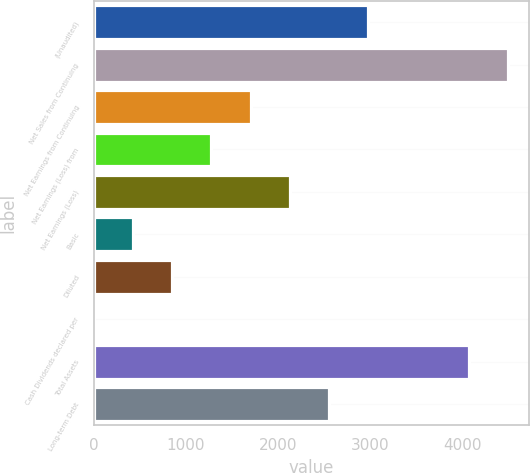<chart> <loc_0><loc_0><loc_500><loc_500><bar_chart><fcel>(Unaudited)<fcel>Net Sales from Continuing<fcel>Net Earnings from Continuing<fcel>Net Earnings (Loss) from<fcel>Net Earnings (Loss)<fcel>Basic<fcel>Diluted<fcel>Cash Dividends declared per<fcel>Total Assets<fcel>Long-term Debt<nl><fcel>2980.81<fcel>4498.14<fcel>1703.59<fcel>1277.85<fcel>2129.33<fcel>426.37<fcel>852.11<fcel>0.63<fcel>4072.4<fcel>2555.07<nl></chart> 